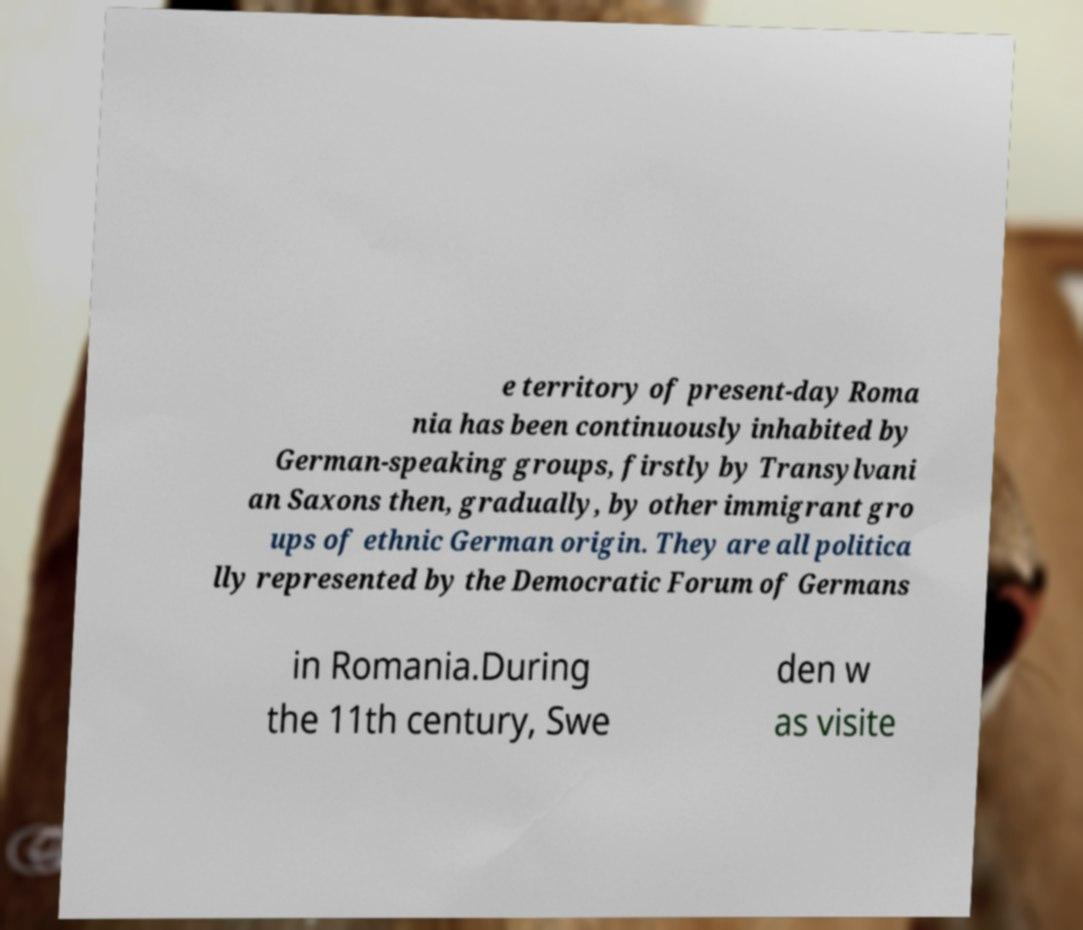I need the written content from this picture converted into text. Can you do that? e territory of present-day Roma nia has been continuously inhabited by German-speaking groups, firstly by Transylvani an Saxons then, gradually, by other immigrant gro ups of ethnic German origin. They are all politica lly represented by the Democratic Forum of Germans in Romania.During the 11th century, Swe den w as visite 